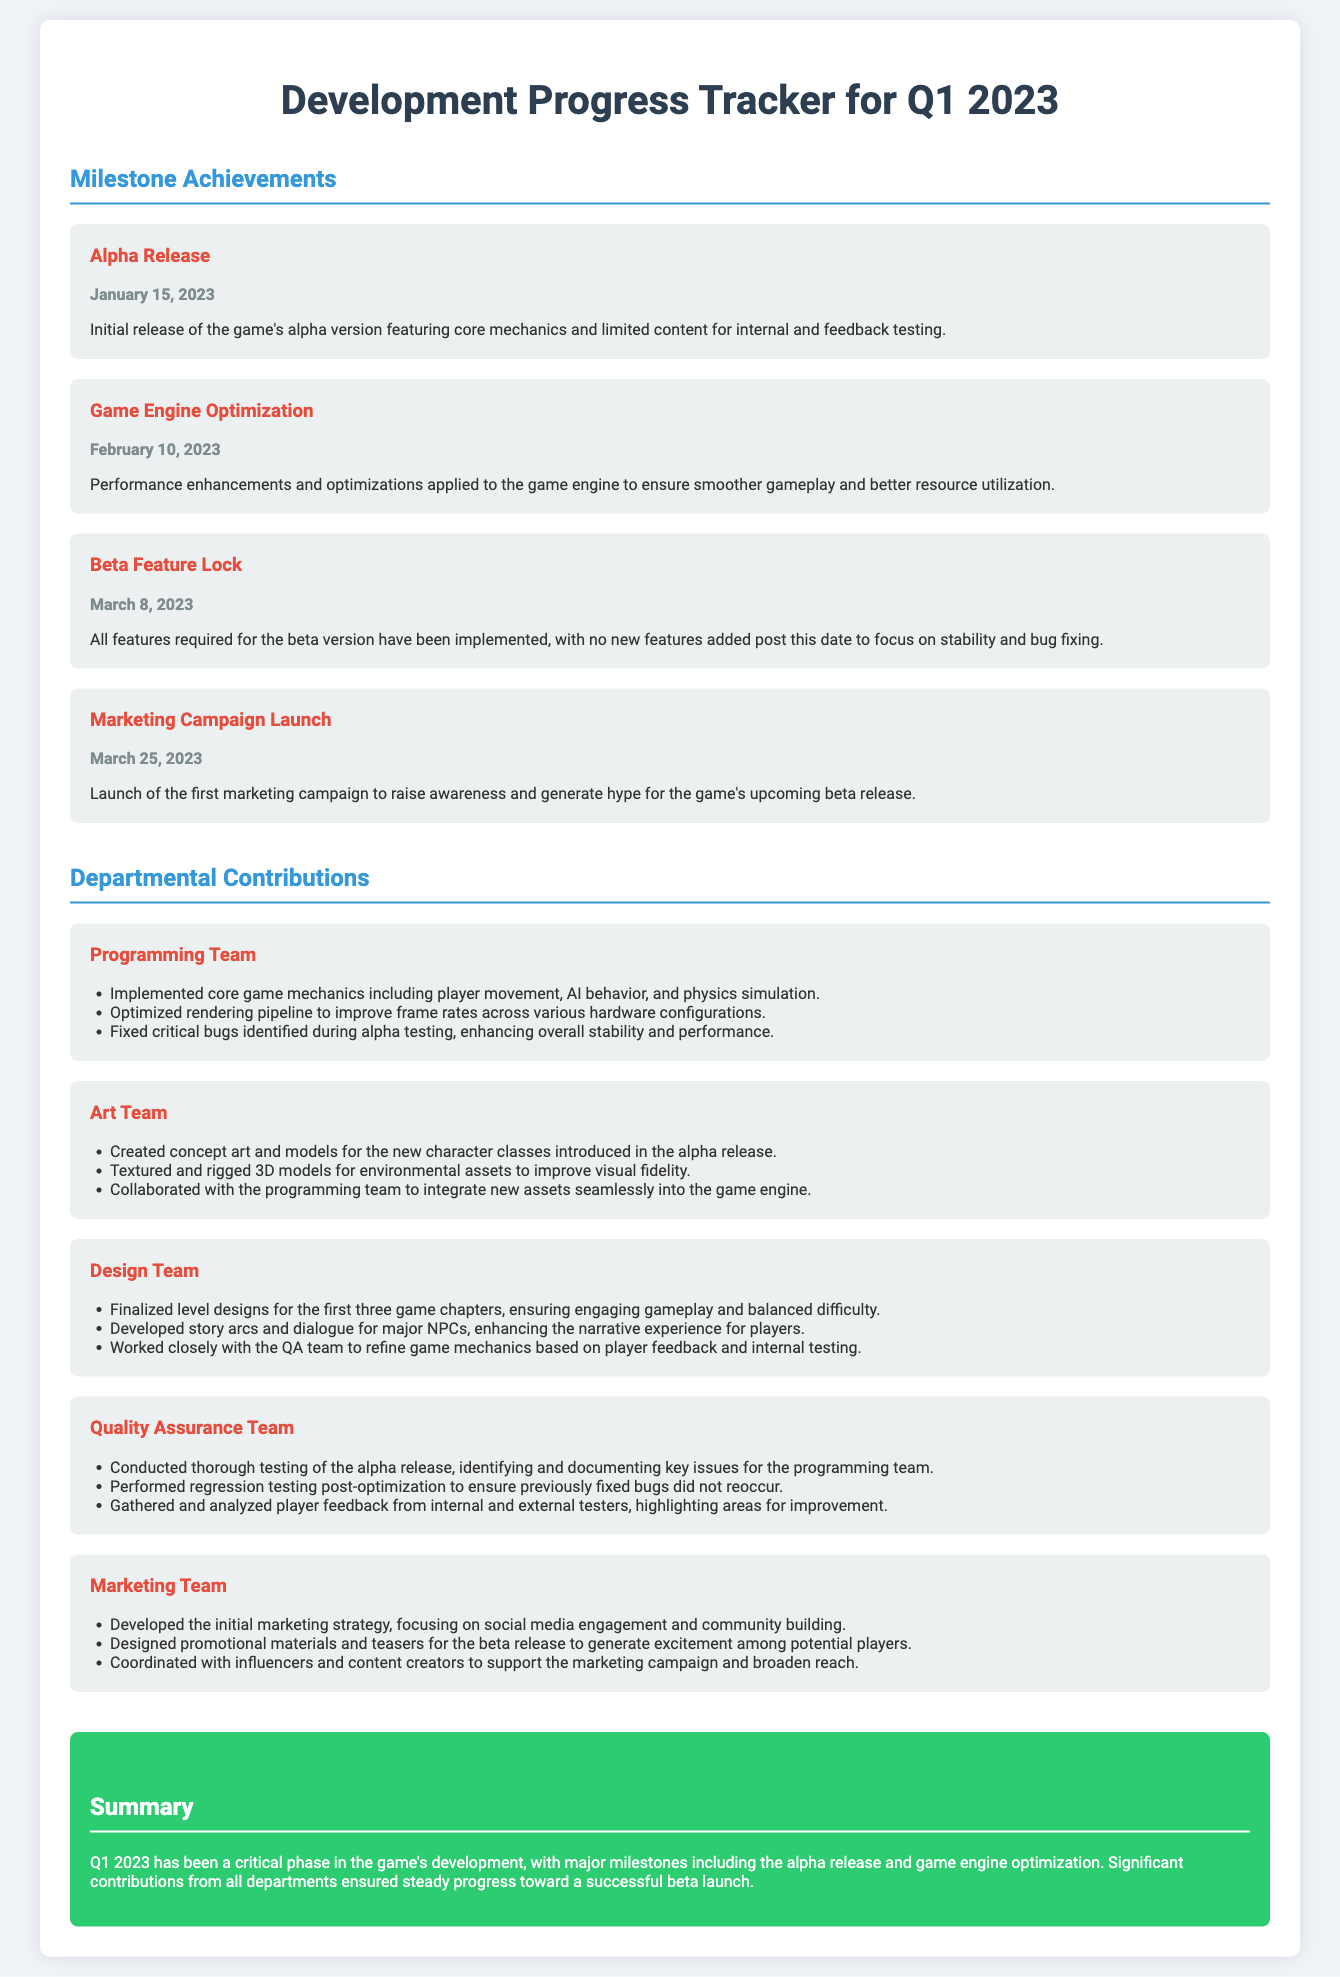What is the date of the Alpha Release? The Alpha Release milestone is dated January 15, 2023, as mentioned in the document.
Answer: January 15, 2023 What was launched on March 25, 2023? The document states that the Marketing Campaign Launch took place on March 25, 2023.
Answer: Marketing Campaign Launch Which department implemented core game mechanics? The Programming Team is responsible for implementing core game mechanics according to the document.
Answer: Programming Team How many major milestones are listed? There are four major milestones detailed in the document.
Answer: Four What contribution did the Art Team make? The Art Team created concept art and models for the new character classes introduced in the alpha release.
Answer: Created concept art and models What is the focus of the Marketing Team's strategy? The Marketing Team's strategy focuses on social media engagement and community building.
Answer: Social media engagement What happened on March 8, 2023? The Beta Feature Lock was achieved on March 8, 2023, as stated in the document.
Answer: Beta Feature Lock How did the Quality Assurance Team contribute? The Quality Assurance Team conducted thorough testing of the alpha release to identify issues.
Answer: Conducted thorough testing What is the overall summary of Q1 2023 development progress? The summary indicates that Q1 2023 was critical, leading to a successful beta launch with major milestones.
Answer: Critical phase for beta launch 